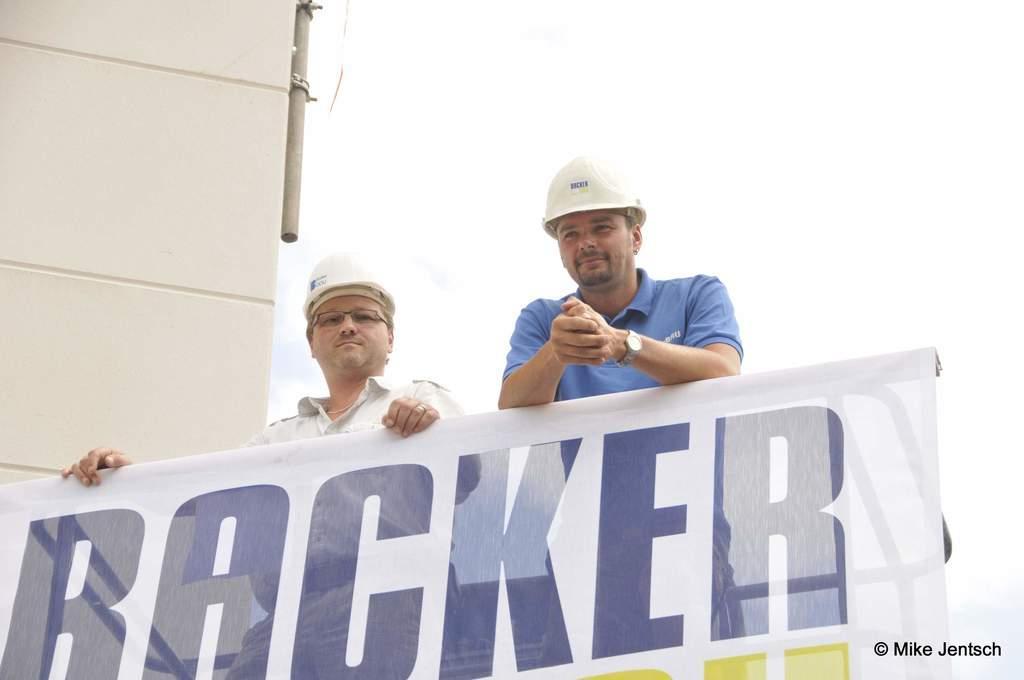Can you describe this image briefly? In this image two person are behind the banner. They are wearing helmet. A person wearing a blue shirt is having a watch. A person wearing a white shirt is having spectacles. Beside them there is a wall. 